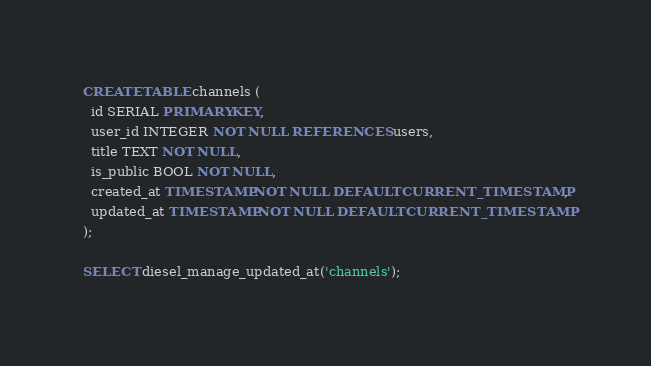Convert code to text. <code><loc_0><loc_0><loc_500><loc_500><_SQL_>CREATE TABLE channels (
  id SERIAL PRIMARY KEY,
  user_id INTEGER NOT NULL REFERENCES users,
  title TEXT NOT NULL,
  is_public BOOL NOT NULL,
  created_at TIMESTAMP NOT NULL DEFAULT CURRENT_TIMESTAMP,
  updated_at TIMESTAMP NOT NULL DEFAULT CURRENT_TIMESTAMP
);

SELECT diesel_manage_updated_at('channels');
</code> 